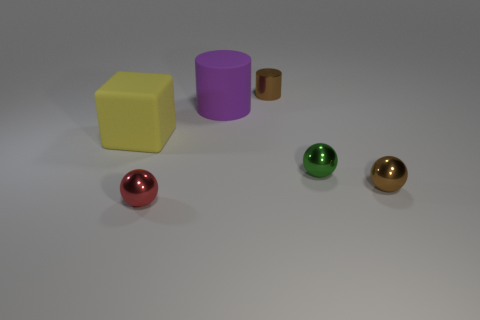How many small brown metal cubes are there?
Offer a terse response. 0. Is the number of big matte objects that are right of the big purple cylinder less than the number of blue objects?
Ensure brevity in your answer.  No. Is the material of the thing that is on the left side of the tiny red metal ball the same as the large purple thing?
Provide a short and direct response. Yes. The brown metal thing that is right of the small brown metallic thing behind the brown metallic object that is in front of the large yellow matte object is what shape?
Your response must be concise. Sphere. Are there any brown objects of the same size as the green thing?
Keep it short and to the point. Yes. How big is the purple matte cylinder?
Your answer should be very brief. Large. What number of red rubber things have the same size as the purple matte object?
Offer a very short reply. 0. Are there fewer large yellow matte things to the right of the cube than yellow cubes to the right of the green sphere?
Ensure brevity in your answer.  No. What size is the brown metallic object that is behind the cylinder on the left side of the tiny brown thing that is behind the purple rubber cylinder?
Keep it short and to the point. Small. There is a metallic thing that is both to the left of the small green metallic ball and in front of the small cylinder; how big is it?
Your answer should be very brief. Small. 